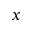Convert formula to latex. <formula><loc_0><loc_0><loc_500><loc_500>x</formula> 